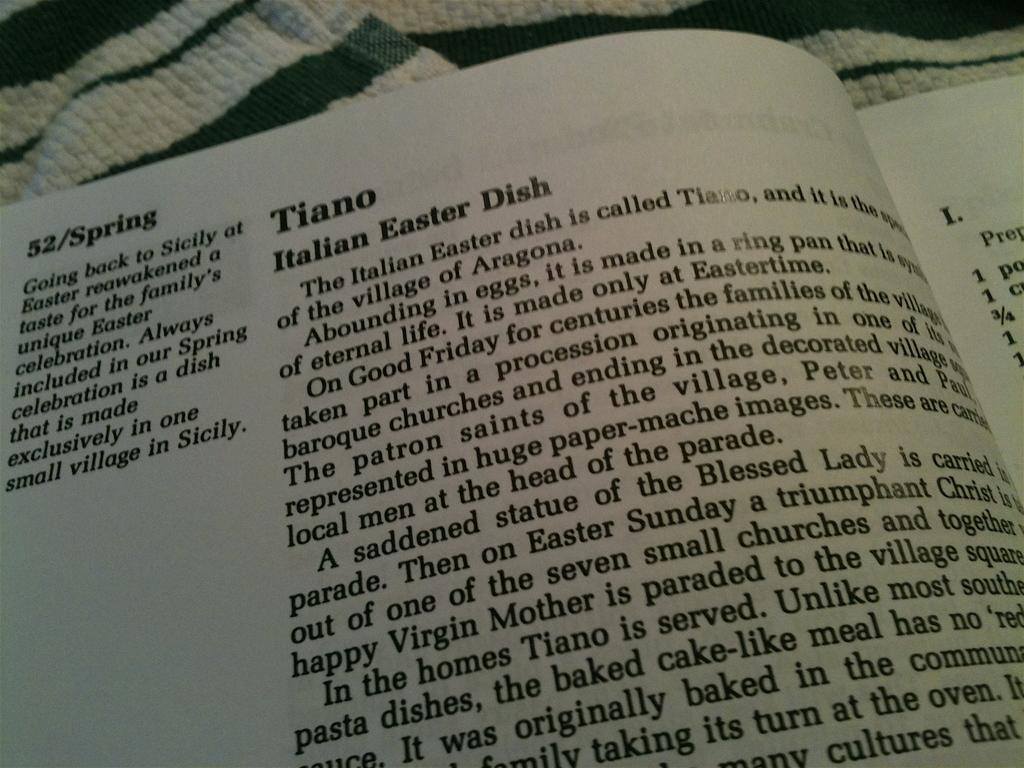What is the name of the italian easter dish?
Offer a very short reply. Tiano. What holiday is this dish often made?
Your answer should be compact. Easter. 